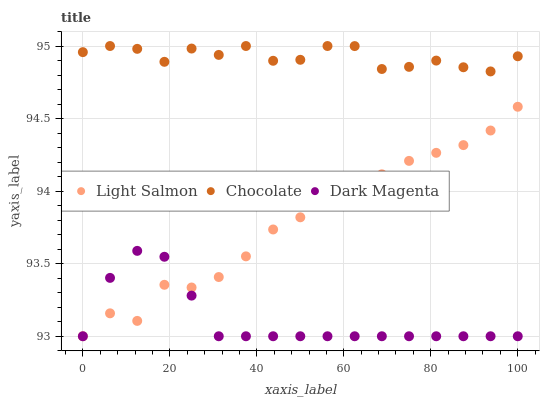Does Dark Magenta have the minimum area under the curve?
Answer yes or no. Yes. Does Chocolate have the maximum area under the curve?
Answer yes or no. Yes. Does Chocolate have the minimum area under the curve?
Answer yes or no. No. Does Dark Magenta have the maximum area under the curve?
Answer yes or no. No. Is Dark Magenta the smoothest?
Answer yes or no. Yes. Is Light Salmon the roughest?
Answer yes or no. Yes. Is Chocolate the smoothest?
Answer yes or no. No. Is Chocolate the roughest?
Answer yes or no. No. Does Light Salmon have the lowest value?
Answer yes or no. Yes. Does Chocolate have the lowest value?
Answer yes or no. No. Does Chocolate have the highest value?
Answer yes or no. Yes. Does Dark Magenta have the highest value?
Answer yes or no. No. Is Light Salmon less than Chocolate?
Answer yes or no. Yes. Is Chocolate greater than Dark Magenta?
Answer yes or no. Yes. Does Dark Magenta intersect Light Salmon?
Answer yes or no. Yes. Is Dark Magenta less than Light Salmon?
Answer yes or no. No. Is Dark Magenta greater than Light Salmon?
Answer yes or no. No. Does Light Salmon intersect Chocolate?
Answer yes or no. No. 